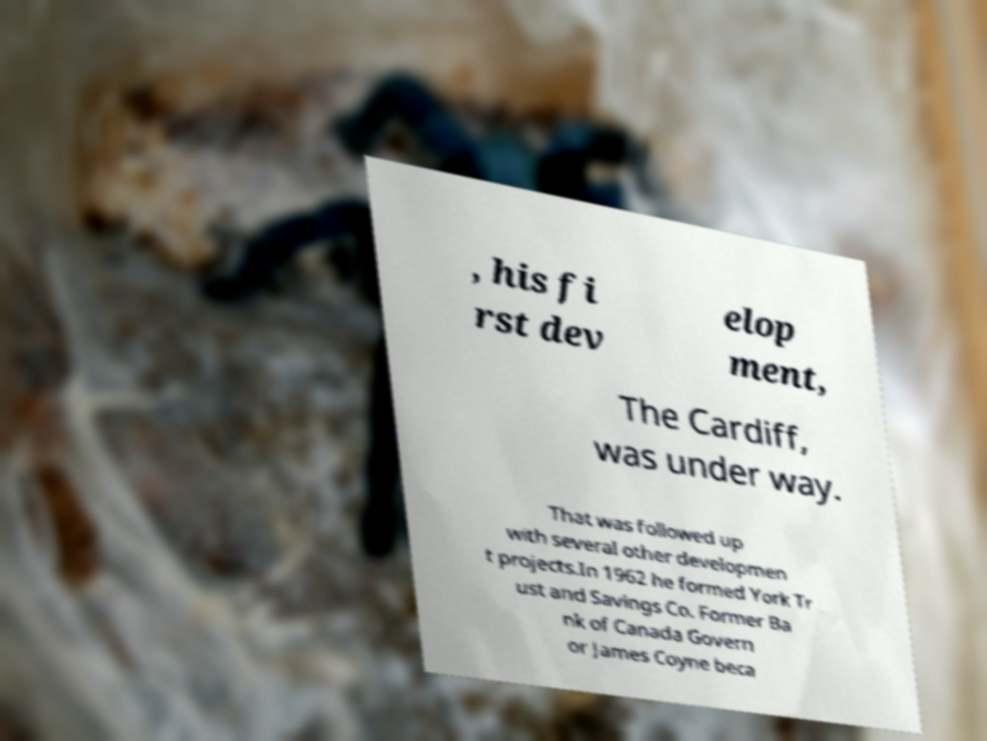For documentation purposes, I need the text within this image transcribed. Could you provide that? , his fi rst dev elop ment, The Cardiff, was under way. That was followed up with several other developmen t projects.In 1962 he formed York Tr ust and Savings Co. Former Ba nk of Canada Govern or James Coyne beca 